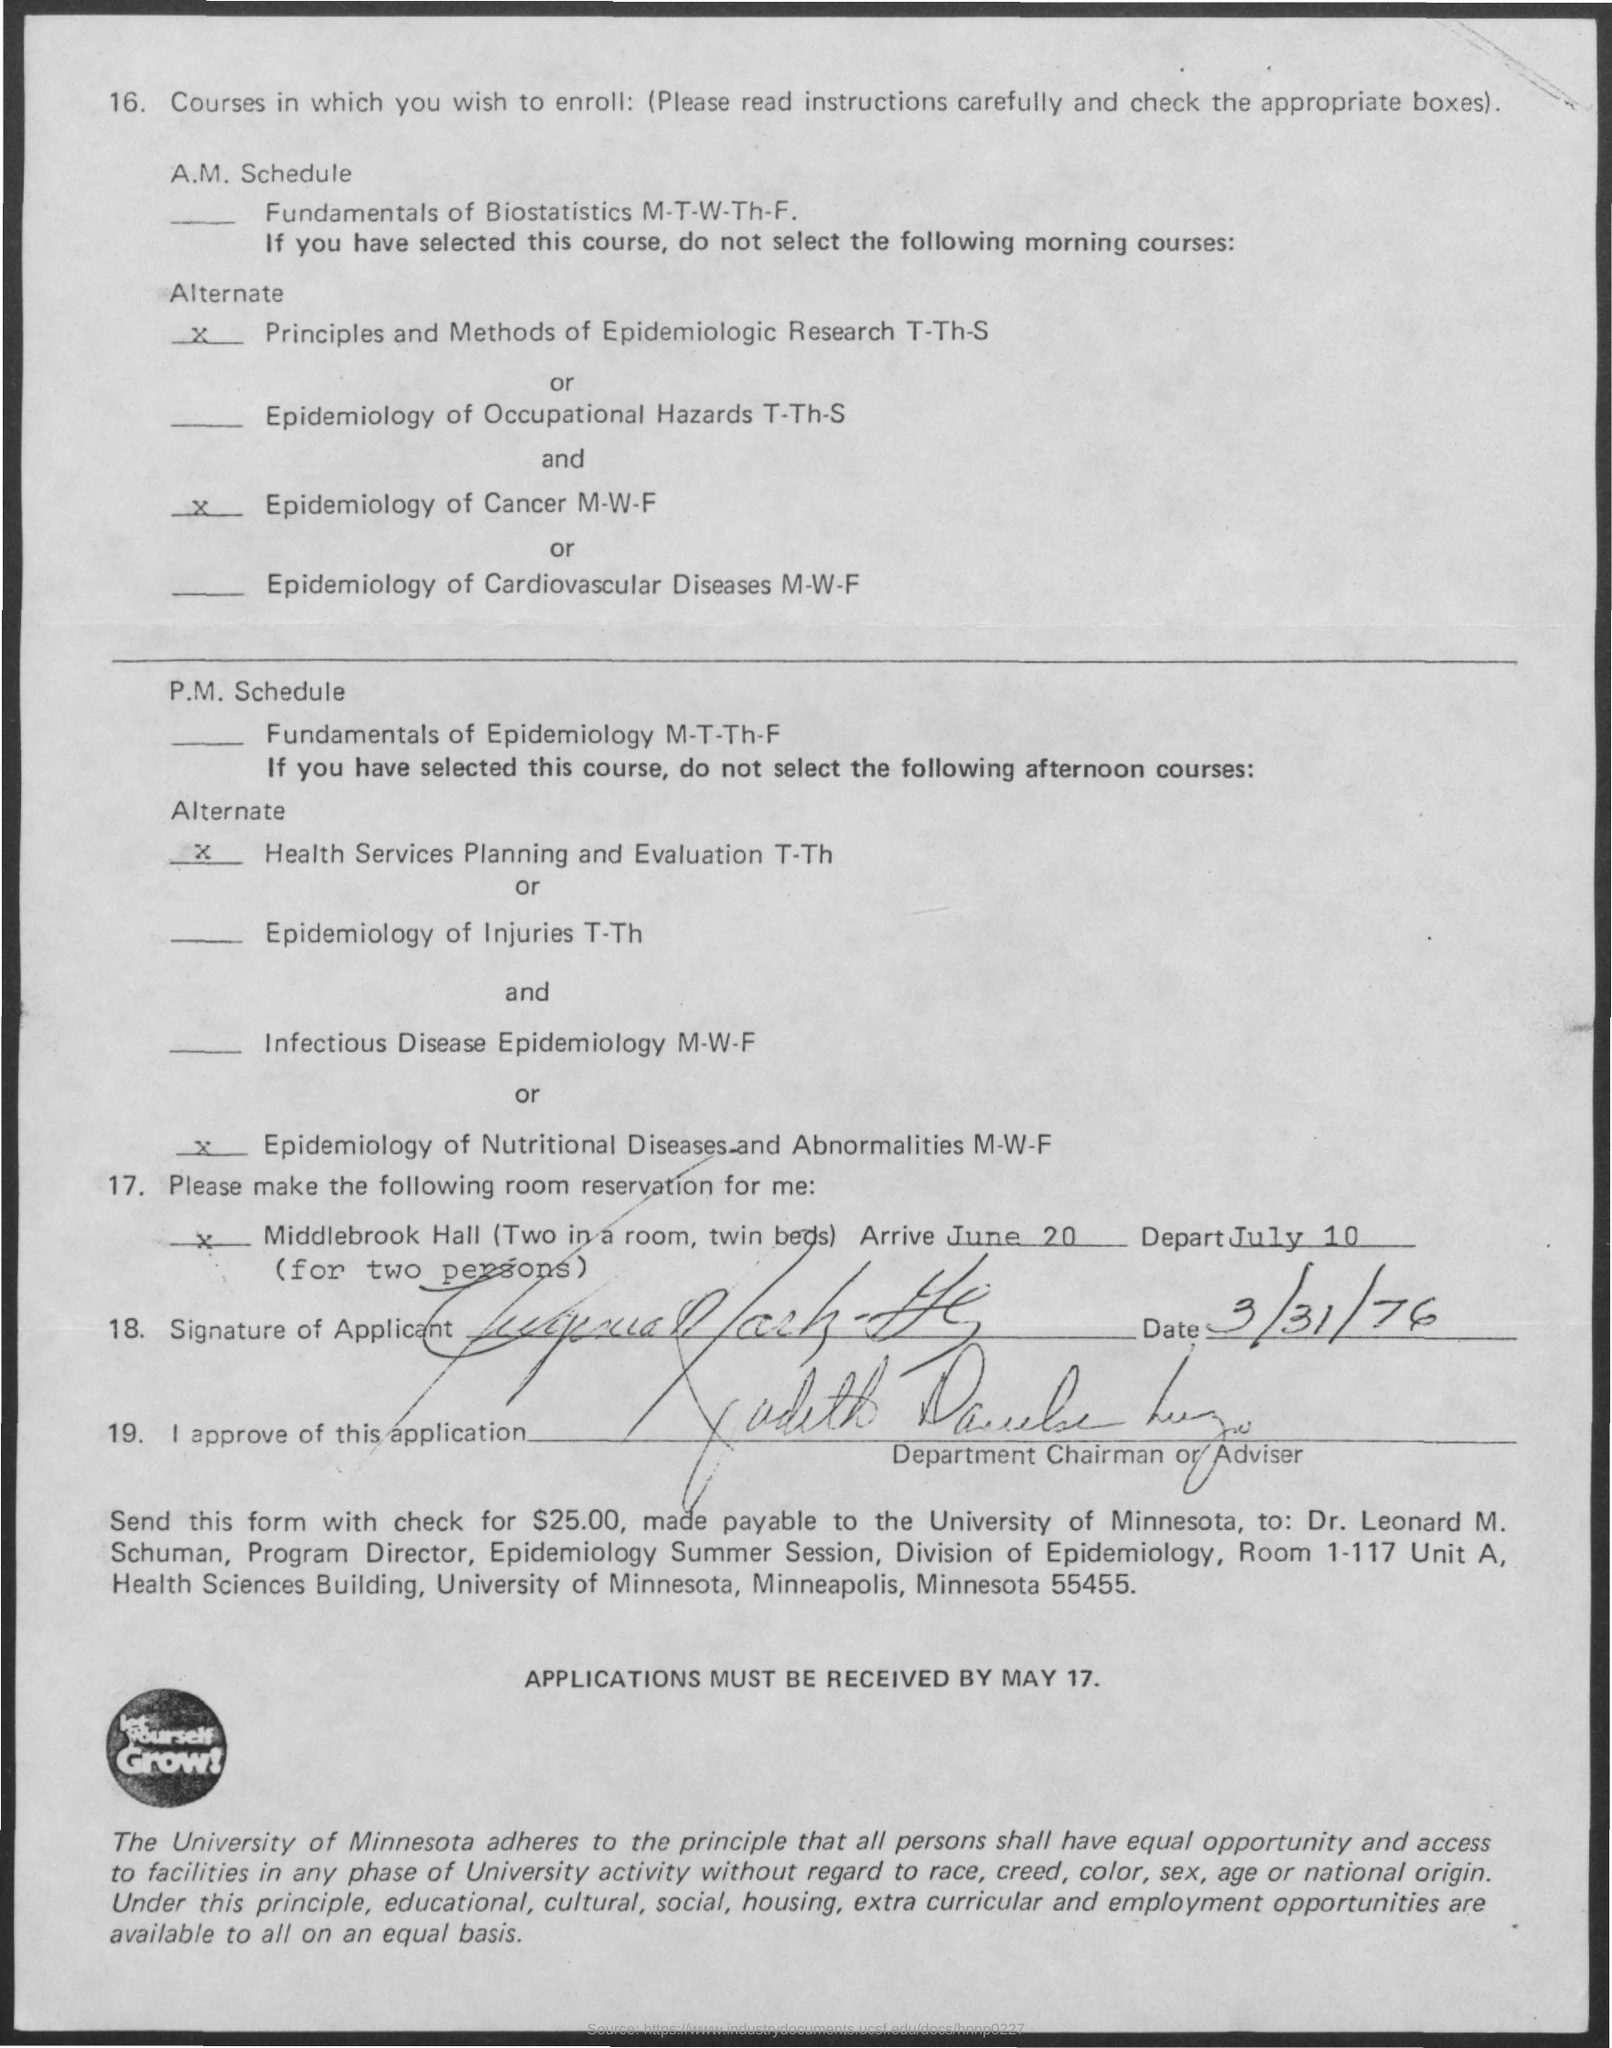What is the arrive date mentioned in the given letter ?
Your response must be concise. June 20. What is the depart date mentioned in the given letter ?
Offer a very short reply. July 10. On which date the signature was done in the letter ?
Offer a terse response. 3/31/76. 